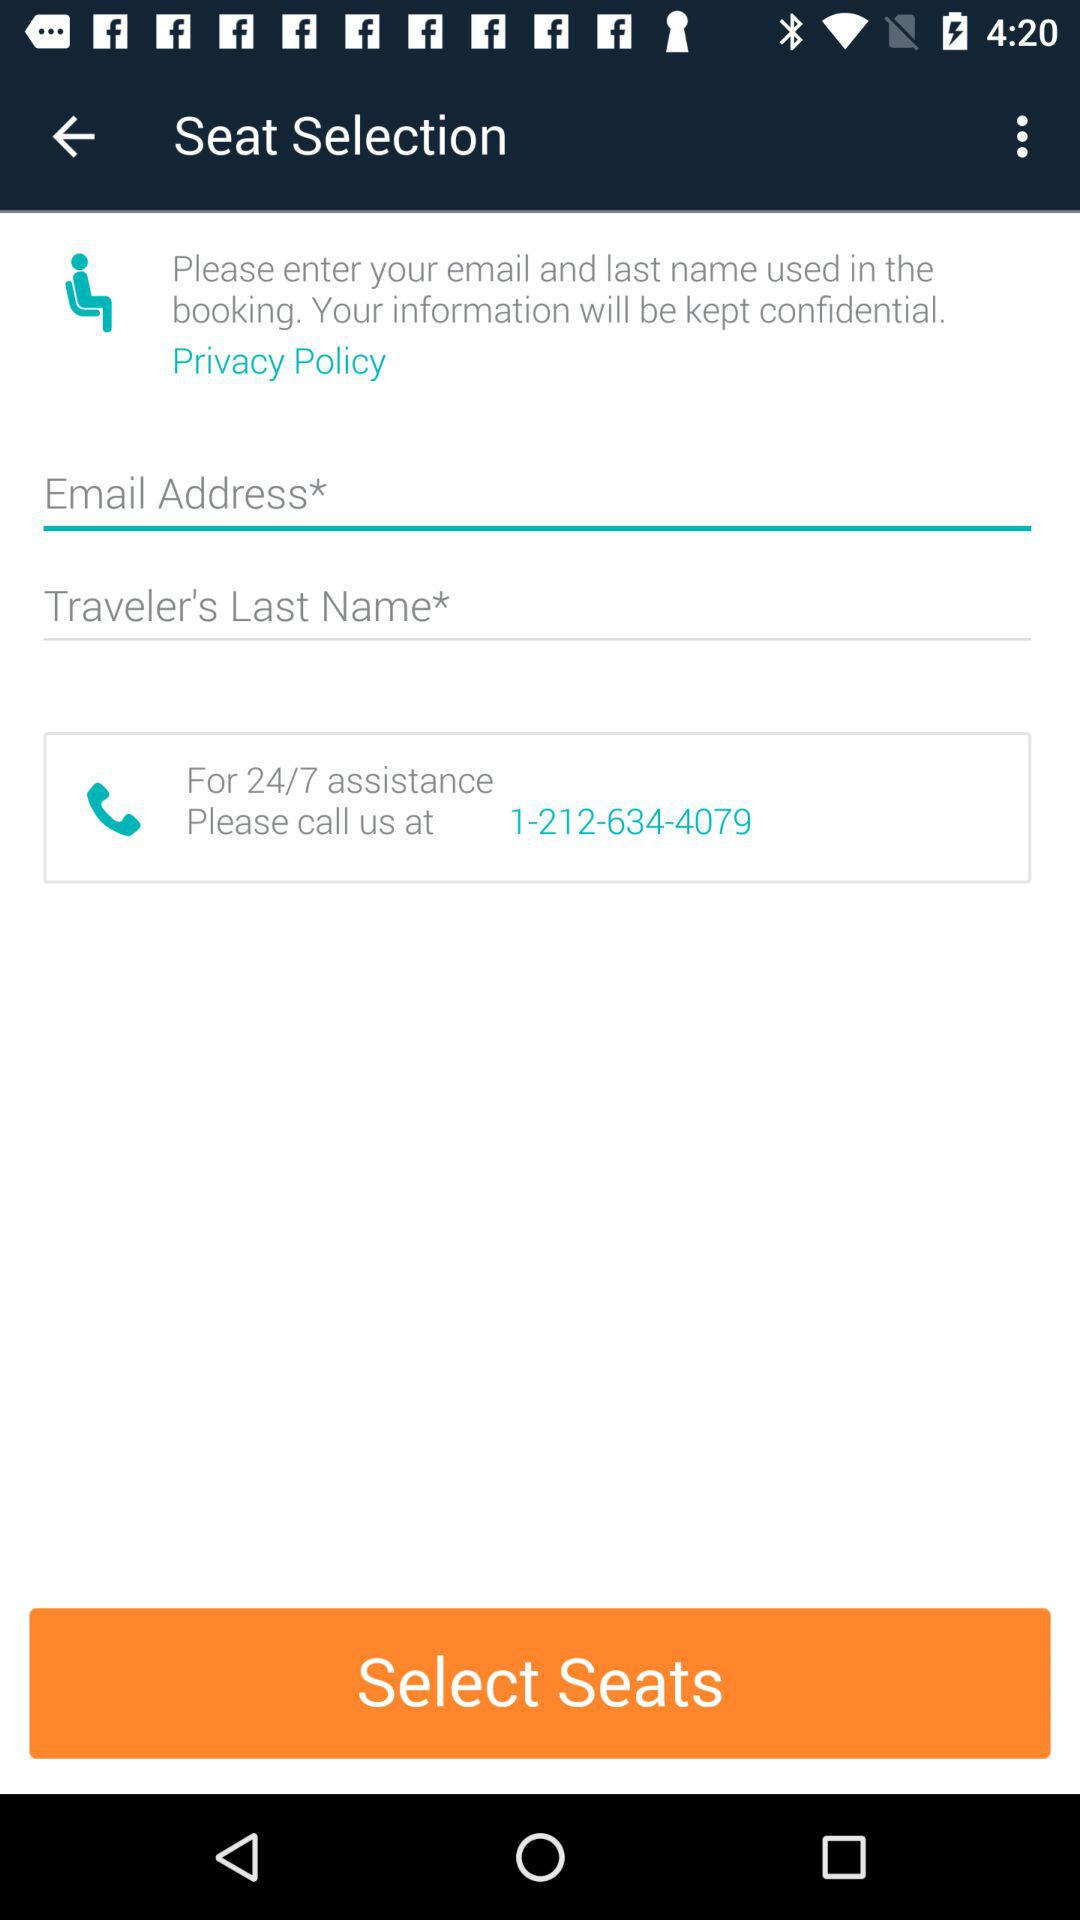What is the traveler's last name?
When the provided information is insufficient, respond with <no answer>. <no answer> 